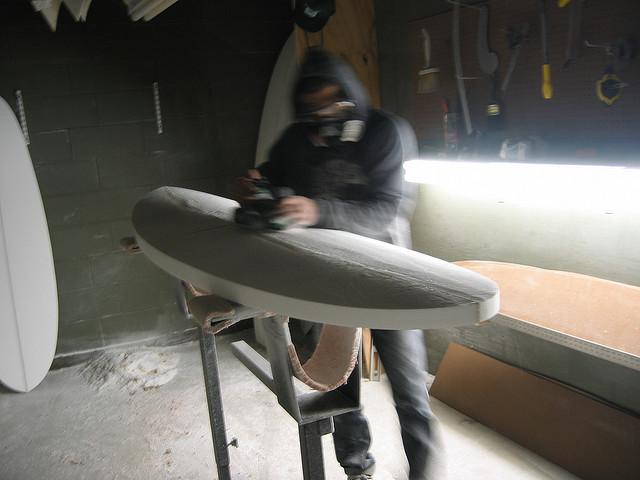Does it look cold?
Short answer required. Yes. Is this guy breaking in?
Short answer required. No. Does the paint have a gloss or matte finish?
Short answer required. Matte. What is he making?
Keep it brief. Surfboard. 